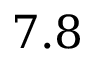<formula> <loc_0><loc_0><loc_500><loc_500>7 . 8</formula> 